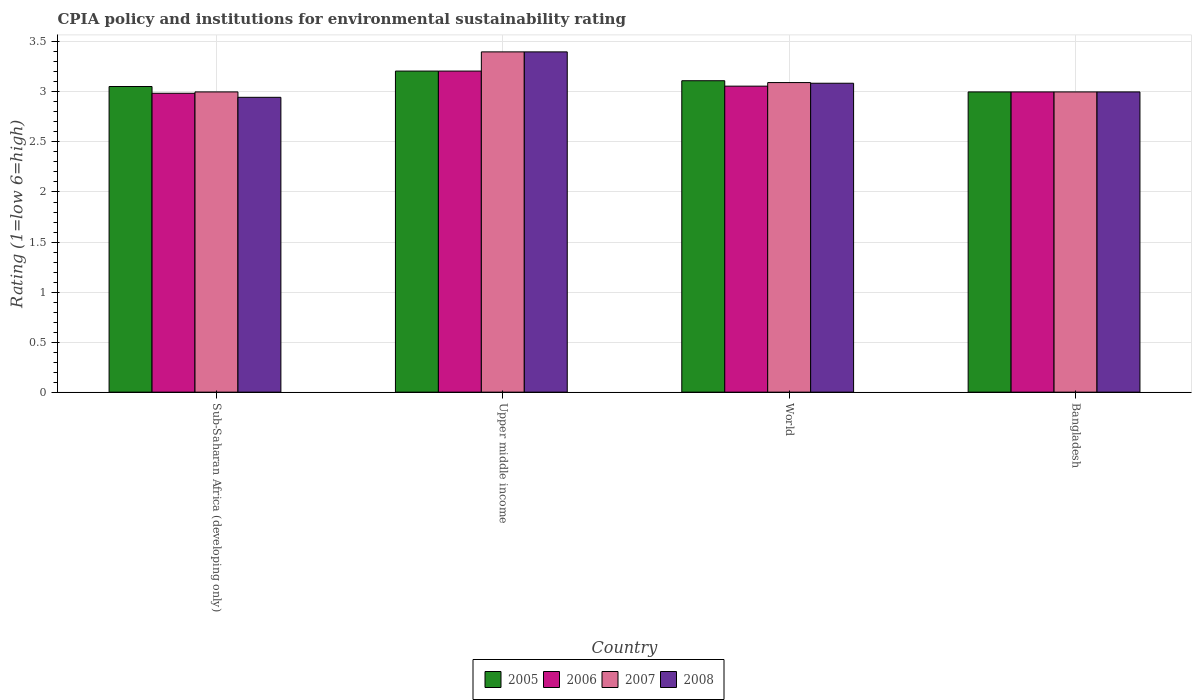How many different coloured bars are there?
Your answer should be very brief. 4. What is the label of the 2nd group of bars from the left?
Your answer should be very brief. Upper middle income. In how many cases, is the number of bars for a given country not equal to the number of legend labels?
Keep it short and to the point. 0. What is the CPIA rating in 2005 in Sub-Saharan Africa (developing only)?
Offer a very short reply. 3.05. Across all countries, what is the maximum CPIA rating in 2008?
Your response must be concise. 3.4. Across all countries, what is the minimum CPIA rating in 2005?
Provide a succinct answer. 3. In which country was the CPIA rating in 2008 maximum?
Your response must be concise. Upper middle income. In which country was the CPIA rating in 2007 minimum?
Offer a very short reply. Sub-Saharan Africa (developing only). What is the total CPIA rating in 2007 in the graph?
Offer a terse response. 12.49. What is the difference between the CPIA rating in 2007 in Bangladesh and that in World?
Offer a very short reply. -0.09. What is the difference between the CPIA rating in 2007 in Sub-Saharan Africa (developing only) and the CPIA rating in 2006 in Bangladesh?
Your response must be concise. 0. What is the average CPIA rating in 2008 per country?
Keep it short and to the point. 3.11. What is the difference between the CPIA rating of/in 2008 and CPIA rating of/in 2005 in Sub-Saharan Africa (developing only)?
Your answer should be compact. -0.11. What is the ratio of the CPIA rating in 2008 in Sub-Saharan Africa (developing only) to that in World?
Keep it short and to the point. 0.95. Is the difference between the CPIA rating in 2008 in Bangladesh and Sub-Saharan Africa (developing only) greater than the difference between the CPIA rating in 2005 in Bangladesh and Sub-Saharan Africa (developing only)?
Your response must be concise. Yes. What is the difference between the highest and the second highest CPIA rating in 2007?
Provide a short and direct response. 0.09. What is the difference between the highest and the lowest CPIA rating in 2008?
Give a very brief answer. 0.45. Is it the case that in every country, the sum of the CPIA rating in 2008 and CPIA rating in 2007 is greater than the sum of CPIA rating in 2006 and CPIA rating in 2005?
Offer a very short reply. No. Is it the case that in every country, the sum of the CPIA rating in 2008 and CPIA rating in 2006 is greater than the CPIA rating in 2005?
Ensure brevity in your answer.  Yes. Are all the bars in the graph horizontal?
Offer a terse response. No. How many countries are there in the graph?
Your answer should be compact. 4. What is the difference between two consecutive major ticks on the Y-axis?
Provide a short and direct response. 0.5. Are the values on the major ticks of Y-axis written in scientific E-notation?
Offer a terse response. No. Where does the legend appear in the graph?
Keep it short and to the point. Bottom center. How many legend labels are there?
Your answer should be compact. 4. What is the title of the graph?
Your response must be concise. CPIA policy and institutions for environmental sustainability rating. What is the Rating (1=low 6=high) of 2005 in Sub-Saharan Africa (developing only)?
Offer a very short reply. 3.05. What is the Rating (1=low 6=high) of 2006 in Sub-Saharan Africa (developing only)?
Offer a very short reply. 2.99. What is the Rating (1=low 6=high) of 2008 in Sub-Saharan Africa (developing only)?
Provide a succinct answer. 2.95. What is the Rating (1=low 6=high) of 2005 in Upper middle income?
Your answer should be very brief. 3.21. What is the Rating (1=low 6=high) of 2006 in Upper middle income?
Provide a succinct answer. 3.21. What is the Rating (1=low 6=high) in 2008 in Upper middle income?
Offer a very short reply. 3.4. What is the Rating (1=low 6=high) in 2005 in World?
Provide a short and direct response. 3.11. What is the Rating (1=low 6=high) in 2006 in World?
Offer a terse response. 3.06. What is the Rating (1=low 6=high) of 2007 in World?
Offer a terse response. 3.09. What is the Rating (1=low 6=high) of 2008 in World?
Make the answer very short. 3.09. What is the Rating (1=low 6=high) of 2005 in Bangladesh?
Provide a short and direct response. 3. What is the Rating (1=low 6=high) of 2006 in Bangladesh?
Make the answer very short. 3. What is the Rating (1=low 6=high) of 2007 in Bangladesh?
Your answer should be compact. 3. Across all countries, what is the maximum Rating (1=low 6=high) in 2005?
Provide a succinct answer. 3.21. Across all countries, what is the maximum Rating (1=low 6=high) of 2006?
Your answer should be compact. 3.21. Across all countries, what is the maximum Rating (1=low 6=high) in 2007?
Your response must be concise. 3.4. Across all countries, what is the maximum Rating (1=low 6=high) in 2008?
Ensure brevity in your answer.  3.4. Across all countries, what is the minimum Rating (1=low 6=high) of 2006?
Keep it short and to the point. 2.99. Across all countries, what is the minimum Rating (1=low 6=high) of 2007?
Offer a terse response. 3. Across all countries, what is the minimum Rating (1=low 6=high) in 2008?
Provide a succinct answer. 2.95. What is the total Rating (1=low 6=high) in 2005 in the graph?
Offer a very short reply. 12.37. What is the total Rating (1=low 6=high) in 2006 in the graph?
Your answer should be very brief. 12.25. What is the total Rating (1=low 6=high) in 2007 in the graph?
Your answer should be very brief. 12.49. What is the total Rating (1=low 6=high) in 2008 in the graph?
Provide a succinct answer. 12.43. What is the difference between the Rating (1=low 6=high) in 2005 in Sub-Saharan Africa (developing only) and that in Upper middle income?
Your answer should be compact. -0.15. What is the difference between the Rating (1=low 6=high) of 2006 in Sub-Saharan Africa (developing only) and that in Upper middle income?
Give a very brief answer. -0.22. What is the difference between the Rating (1=low 6=high) in 2007 in Sub-Saharan Africa (developing only) and that in Upper middle income?
Your answer should be very brief. -0.4. What is the difference between the Rating (1=low 6=high) in 2008 in Sub-Saharan Africa (developing only) and that in Upper middle income?
Your answer should be compact. -0.45. What is the difference between the Rating (1=low 6=high) of 2005 in Sub-Saharan Africa (developing only) and that in World?
Provide a short and direct response. -0.06. What is the difference between the Rating (1=low 6=high) in 2006 in Sub-Saharan Africa (developing only) and that in World?
Keep it short and to the point. -0.07. What is the difference between the Rating (1=low 6=high) in 2007 in Sub-Saharan Africa (developing only) and that in World?
Your answer should be very brief. -0.09. What is the difference between the Rating (1=low 6=high) in 2008 in Sub-Saharan Africa (developing only) and that in World?
Your answer should be compact. -0.14. What is the difference between the Rating (1=low 6=high) of 2005 in Sub-Saharan Africa (developing only) and that in Bangladesh?
Provide a short and direct response. 0.05. What is the difference between the Rating (1=low 6=high) of 2006 in Sub-Saharan Africa (developing only) and that in Bangladesh?
Offer a terse response. -0.01. What is the difference between the Rating (1=low 6=high) of 2008 in Sub-Saharan Africa (developing only) and that in Bangladesh?
Offer a very short reply. -0.05. What is the difference between the Rating (1=low 6=high) in 2005 in Upper middle income and that in World?
Ensure brevity in your answer.  0.1. What is the difference between the Rating (1=low 6=high) in 2006 in Upper middle income and that in World?
Provide a succinct answer. 0.15. What is the difference between the Rating (1=low 6=high) of 2007 in Upper middle income and that in World?
Keep it short and to the point. 0.31. What is the difference between the Rating (1=low 6=high) in 2008 in Upper middle income and that in World?
Ensure brevity in your answer.  0.31. What is the difference between the Rating (1=low 6=high) of 2005 in Upper middle income and that in Bangladesh?
Provide a succinct answer. 0.21. What is the difference between the Rating (1=low 6=high) in 2006 in Upper middle income and that in Bangladesh?
Offer a terse response. 0.21. What is the difference between the Rating (1=low 6=high) in 2007 in Upper middle income and that in Bangladesh?
Give a very brief answer. 0.4. What is the difference between the Rating (1=low 6=high) in 2005 in World and that in Bangladesh?
Your answer should be compact. 0.11. What is the difference between the Rating (1=low 6=high) of 2006 in World and that in Bangladesh?
Your answer should be very brief. 0.06. What is the difference between the Rating (1=low 6=high) of 2007 in World and that in Bangladesh?
Ensure brevity in your answer.  0.09. What is the difference between the Rating (1=low 6=high) in 2008 in World and that in Bangladesh?
Provide a succinct answer. 0.09. What is the difference between the Rating (1=low 6=high) of 2005 in Sub-Saharan Africa (developing only) and the Rating (1=low 6=high) of 2006 in Upper middle income?
Give a very brief answer. -0.15. What is the difference between the Rating (1=low 6=high) in 2005 in Sub-Saharan Africa (developing only) and the Rating (1=low 6=high) in 2007 in Upper middle income?
Your answer should be very brief. -0.35. What is the difference between the Rating (1=low 6=high) of 2005 in Sub-Saharan Africa (developing only) and the Rating (1=low 6=high) of 2008 in Upper middle income?
Your answer should be compact. -0.35. What is the difference between the Rating (1=low 6=high) of 2006 in Sub-Saharan Africa (developing only) and the Rating (1=low 6=high) of 2007 in Upper middle income?
Provide a short and direct response. -0.41. What is the difference between the Rating (1=low 6=high) in 2006 in Sub-Saharan Africa (developing only) and the Rating (1=low 6=high) in 2008 in Upper middle income?
Provide a short and direct response. -0.41. What is the difference between the Rating (1=low 6=high) of 2007 in Sub-Saharan Africa (developing only) and the Rating (1=low 6=high) of 2008 in Upper middle income?
Provide a short and direct response. -0.4. What is the difference between the Rating (1=low 6=high) of 2005 in Sub-Saharan Africa (developing only) and the Rating (1=low 6=high) of 2006 in World?
Your answer should be compact. -0. What is the difference between the Rating (1=low 6=high) of 2005 in Sub-Saharan Africa (developing only) and the Rating (1=low 6=high) of 2007 in World?
Give a very brief answer. -0.04. What is the difference between the Rating (1=low 6=high) in 2005 in Sub-Saharan Africa (developing only) and the Rating (1=low 6=high) in 2008 in World?
Provide a succinct answer. -0.03. What is the difference between the Rating (1=low 6=high) of 2006 in Sub-Saharan Africa (developing only) and the Rating (1=low 6=high) of 2007 in World?
Provide a succinct answer. -0.11. What is the difference between the Rating (1=low 6=high) in 2006 in Sub-Saharan Africa (developing only) and the Rating (1=low 6=high) in 2008 in World?
Your answer should be very brief. -0.1. What is the difference between the Rating (1=low 6=high) of 2007 in Sub-Saharan Africa (developing only) and the Rating (1=low 6=high) of 2008 in World?
Provide a short and direct response. -0.09. What is the difference between the Rating (1=low 6=high) of 2005 in Sub-Saharan Africa (developing only) and the Rating (1=low 6=high) of 2006 in Bangladesh?
Your answer should be compact. 0.05. What is the difference between the Rating (1=low 6=high) of 2005 in Sub-Saharan Africa (developing only) and the Rating (1=low 6=high) of 2007 in Bangladesh?
Provide a succinct answer. 0.05. What is the difference between the Rating (1=low 6=high) of 2005 in Sub-Saharan Africa (developing only) and the Rating (1=low 6=high) of 2008 in Bangladesh?
Provide a short and direct response. 0.05. What is the difference between the Rating (1=low 6=high) of 2006 in Sub-Saharan Africa (developing only) and the Rating (1=low 6=high) of 2007 in Bangladesh?
Give a very brief answer. -0.01. What is the difference between the Rating (1=low 6=high) of 2006 in Sub-Saharan Africa (developing only) and the Rating (1=low 6=high) of 2008 in Bangladesh?
Your answer should be compact. -0.01. What is the difference between the Rating (1=low 6=high) in 2005 in Upper middle income and the Rating (1=low 6=high) in 2006 in World?
Ensure brevity in your answer.  0.15. What is the difference between the Rating (1=low 6=high) in 2005 in Upper middle income and the Rating (1=low 6=high) in 2007 in World?
Your answer should be compact. 0.12. What is the difference between the Rating (1=low 6=high) in 2005 in Upper middle income and the Rating (1=low 6=high) in 2008 in World?
Your answer should be very brief. 0.12. What is the difference between the Rating (1=low 6=high) of 2006 in Upper middle income and the Rating (1=low 6=high) of 2007 in World?
Give a very brief answer. 0.12. What is the difference between the Rating (1=low 6=high) of 2006 in Upper middle income and the Rating (1=low 6=high) of 2008 in World?
Your answer should be compact. 0.12. What is the difference between the Rating (1=low 6=high) in 2007 in Upper middle income and the Rating (1=low 6=high) in 2008 in World?
Offer a terse response. 0.31. What is the difference between the Rating (1=low 6=high) of 2005 in Upper middle income and the Rating (1=low 6=high) of 2006 in Bangladesh?
Ensure brevity in your answer.  0.21. What is the difference between the Rating (1=low 6=high) in 2005 in Upper middle income and the Rating (1=low 6=high) in 2007 in Bangladesh?
Your answer should be very brief. 0.21. What is the difference between the Rating (1=low 6=high) of 2005 in Upper middle income and the Rating (1=low 6=high) of 2008 in Bangladesh?
Ensure brevity in your answer.  0.21. What is the difference between the Rating (1=low 6=high) of 2006 in Upper middle income and the Rating (1=low 6=high) of 2007 in Bangladesh?
Provide a succinct answer. 0.21. What is the difference between the Rating (1=low 6=high) of 2006 in Upper middle income and the Rating (1=low 6=high) of 2008 in Bangladesh?
Your response must be concise. 0.21. What is the difference between the Rating (1=low 6=high) in 2007 in Upper middle income and the Rating (1=low 6=high) in 2008 in Bangladesh?
Your answer should be very brief. 0.4. What is the difference between the Rating (1=low 6=high) in 2005 in World and the Rating (1=low 6=high) in 2006 in Bangladesh?
Ensure brevity in your answer.  0.11. What is the difference between the Rating (1=low 6=high) of 2005 in World and the Rating (1=low 6=high) of 2007 in Bangladesh?
Offer a terse response. 0.11. What is the difference between the Rating (1=low 6=high) in 2005 in World and the Rating (1=low 6=high) in 2008 in Bangladesh?
Offer a terse response. 0.11. What is the difference between the Rating (1=low 6=high) in 2006 in World and the Rating (1=low 6=high) in 2007 in Bangladesh?
Your answer should be compact. 0.06. What is the difference between the Rating (1=low 6=high) in 2006 in World and the Rating (1=low 6=high) in 2008 in Bangladesh?
Provide a succinct answer. 0.06. What is the difference between the Rating (1=low 6=high) of 2007 in World and the Rating (1=low 6=high) of 2008 in Bangladesh?
Provide a succinct answer. 0.09. What is the average Rating (1=low 6=high) in 2005 per country?
Provide a succinct answer. 3.09. What is the average Rating (1=low 6=high) of 2006 per country?
Your response must be concise. 3.06. What is the average Rating (1=low 6=high) in 2007 per country?
Make the answer very short. 3.12. What is the average Rating (1=low 6=high) of 2008 per country?
Keep it short and to the point. 3.11. What is the difference between the Rating (1=low 6=high) in 2005 and Rating (1=low 6=high) in 2006 in Sub-Saharan Africa (developing only)?
Ensure brevity in your answer.  0.07. What is the difference between the Rating (1=low 6=high) in 2005 and Rating (1=low 6=high) in 2007 in Sub-Saharan Africa (developing only)?
Your response must be concise. 0.05. What is the difference between the Rating (1=low 6=high) in 2005 and Rating (1=low 6=high) in 2008 in Sub-Saharan Africa (developing only)?
Provide a short and direct response. 0.11. What is the difference between the Rating (1=low 6=high) in 2006 and Rating (1=low 6=high) in 2007 in Sub-Saharan Africa (developing only)?
Ensure brevity in your answer.  -0.01. What is the difference between the Rating (1=low 6=high) in 2006 and Rating (1=low 6=high) in 2008 in Sub-Saharan Africa (developing only)?
Offer a terse response. 0.04. What is the difference between the Rating (1=low 6=high) in 2007 and Rating (1=low 6=high) in 2008 in Sub-Saharan Africa (developing only)?
Give a very brief answer. 0.05. What is the difference between the Rating (1=low 6=high) of 2005 and Rating (1=low 6=high) of 2007 in Upper middle income?
Your response must be concise. -0.19. What is the difference between the Rating (1=low 6=high) of 2005 and Rating (1=low 6=high) of 2008 in Upper middle income?
Provide a short and direct response. -0.19. What is the difference between the Rating (1=low 6=high) in 2006 and Rating (1=low 6=high) in 2007 in Upper middle income?
Your answer should be compact. -0.19. What is the difference between the Rating (1=low 6=high) of 2006 and Rating (1=low 6=high) of 2008 in Upper middle income?
Give a very brief answer. -0.19. What is the difference between the Rating (1=low 6=high) of 2007 and Rating (1=low 6=high) of 2008 in Upper middle income?
Offer a terse response. 0. What is the difference between the Rating (1=low 6=high) of 2005 and Rating (1=low 6=high) of 2006 in World?
Offer a terse response. 0.05. What is the difference between the Rating (1=low 6=high) in 2005 and Rating (1=low 6=high) in 2007 in World?
Ensure brevity in your answer.  0.02. What is the difference between the Rating (1=low 6=high) of 2005 and Rating (1=low 6=high) of 2008 in World?
Offer a terse response. 0.03. What is the difference between the Rating (1=low 6=high) in 2006 and Rating (1=low 6=high) in 2007 in World?
Provide a succinct answer. -0.04. What is the difference between the Rating (1=low 6=high) of 2006 and Rating (1=low 6=high) of 2008 in World?
Provide a short and direct response. -0.03. What is the difference between the Rating (1=low 6=high) in 2007 and Rating (1=low 6=high) in 2008 in World?
Offer a terse response. 0.01. What is the difference between the Rating (1=low 6=high) of 2005 and Rating (1=low 6=high) of 2006 in Bangladesh?
Your answer should be very brief. 0. What is the difference between the Rating (1=low 6=high) of 2005 and Rating (1=low 6=high) of 2007 in Bangladesh?
Give a very brief answer. 0. What is the difference between the Rating (1=low 6=high) of 2005 and Rating (1=low 6=high) of 2008 in Bangladesh?
Your answer should be compact. 0. What is the difference between the Rating (1=low 6=high) in 2006 and Rating (1=low 6=high) in 2007 in Bangladesh?
Offer a very short reply. 0. What is the difference between the Rating (1=low 6=high) of 2006 and Rating (1=low 6=high) of 2008 in Bangladesh?
Your answer should be compact. 0. What is the ratio of the Rating (1=low 6=high) in 2005 in Sub-Saharan Africa (developing only) to that in Upper middle income?
Give a very brief answer. 0.95. What is the ratio of the Rating (1=low 6=high) of 2006 in Sub-Saharan Africa (developing only) to that in Upper middle income?
Ensure brevity in your answer.  0.93. What is the ratio of the Rating (1=low 6=high) in 2007 in Sub-Saharan Africa (developing only) to that in Upper middle income?
Keep it short and to the point. 0.88. What is the ratio of the Rating (1=low 6=high) of 2008 in Sub-Saharan Africa (developing only) to that in Upper middle income?
Your answer should be very brief. 0.87. What is the ratio of the Rating (1=low 6=high) in 2005 in Sub-Saharan Africa (developing only) to that in World?
Make the answer very short. 0.98. What is the ratio of the Rating (1=low 6=high) of 2006 in Sub-Saharan Africa (developing only) to that in World?
Provide a succinct answer. 0.98. What is the ratio of the Rating (1=low 6=high) in 2007 in Sub-Saharan Africa (developing only) to that in World?
Keep it short and to the point. 0.97. What is the ratio of the Rating (1=low 6=high) in 2008 in Sub-Saharan Africa (developing only) to that in World?
Provide a short and direct response. 0.95. What is the ratio of the Rating (1=low 6=high) of 2007 in Sub-Saharan Africa (developing only) to that in Bangladesh?
Your response must be concise. 1. What is the ratio of the Rating (1=low 6=high) in 2008 in Sub-Saharan Africa (developing only) to that in Bangladesh?
Your answer should be compact. 0.98. What is the ratio of the Rating (1=low 6=high) of 2005 in Upper middle income to that in World?
Provide a succinct answer. 1.03. What is the ratio of the Rating (1=low 6=high) in 2006 in Upper middle income to that in World?
Ensure brevity in your answer.  1.05. What is the ratio of the Rating (1=low 6=high) of 2007 in Upper middle income to that in World?
Offer a terse response. 1.1. What is the ratio of the Rating (1=low 6=high) of 2008 in Upper middle income to that in World?
Give a very brief answer. 1.1. What is the ratio of the Rating (1=low 6=high) in 2005 in Upper middle income to that in Bangladesh?
Your answer should be very brief. 1.07. What is the ratio of the Rating (1=low 6=high) in 2006 in Upper middle income to that in Bangladesh?
Your answer should be very brief. 1.07. What is the ratio of the Rating (1=low 6=high) in 2007 in Upper middle income to that in Bangladesh?
Provide a succinct answer. 1.13. What is the ratio of the Rating (1=low 6=high) in 2008 in Upper middle income to that in Bangladesh?
Offer a terse response. 1.13. What is the ratio of the Rating (1=low 6=high) of 2005 in World to that in Bangladesh?
Your response must be concise. 1.04. What is the ratio of the Rating (1=low 6=high) of 2006 in World to that in Bangladesh?
Offer a very short reply. 1.02. What is the ratio of the Rating (1=low 6=high) of 2007 in World to that in Bangladesh?
Your response must be concise. 1.03. What is the ratio of the Rating (1=low 6=high) of 2008 in World to that in Bangladesh?
Offer a very short reply. 1.03. What is the difference between the highest and the second highest Rating (1=low 6=high) in 2005?
Provide a succinct answer. 0.1. What is the difference between the highest and the second highest Rating (1=low 6=high) of 2006?
Give a very brief answer. 0.15. What is the difference between the highest and the second highest Rating (1=low 6=high) in 2007?
Offer a very short reply. 0.31. What is the difference between the highest and the second highest Rating (1=low 6=high) in 2008?
Offer a terse response. 0.31. What is the difference between the highest and the lowest Rating (1=low 6=high) of 2005?
Offer a very short reply. 0.21. What is the difference between the highest and the lowest Rating (1=low 6=high) in 2006?
Offer a very short reply. 0.22. What is the difference between the highest and the lowest Rating (1=low 6=high) in 2008?
Make the answer very short. 0.45. 